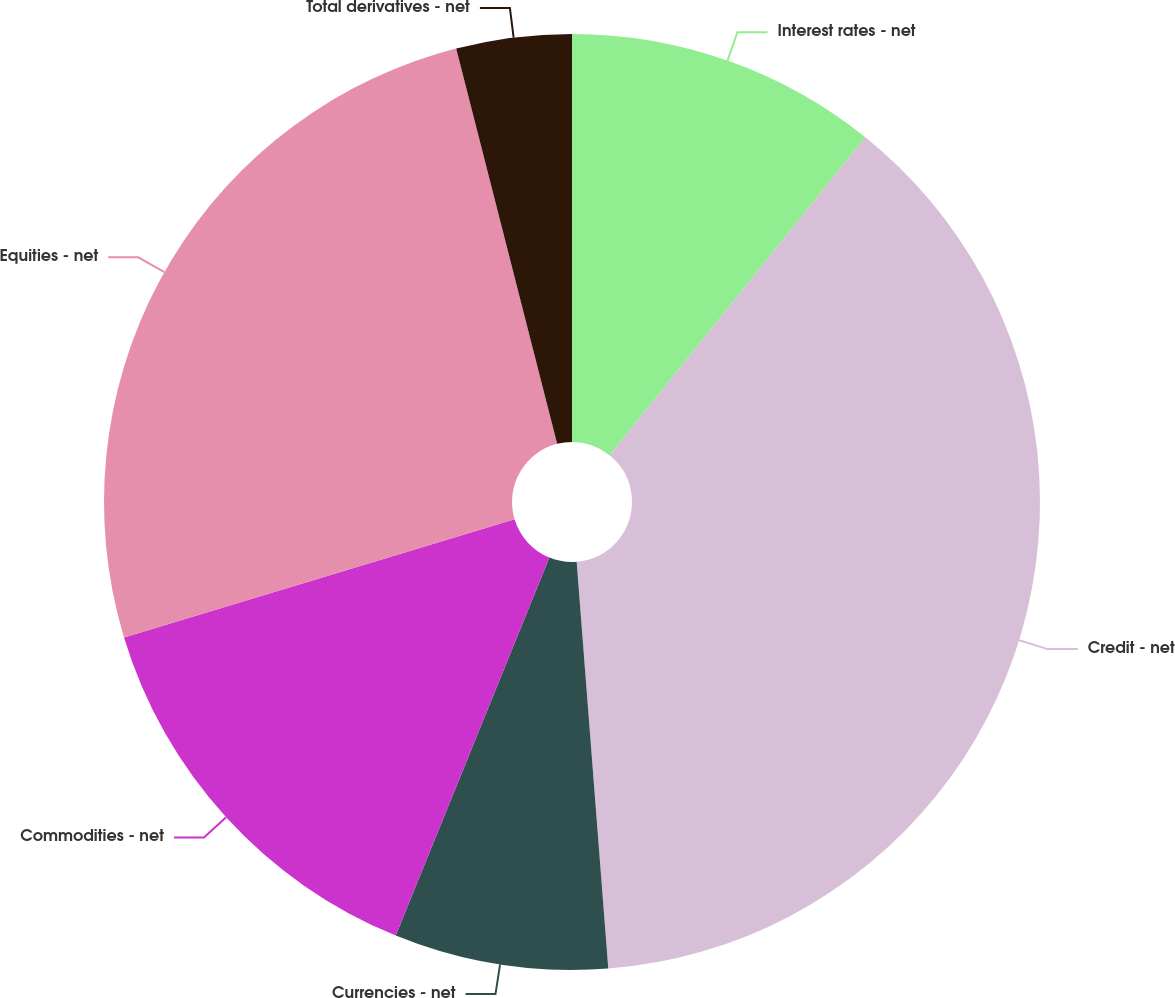<chart> <loc_0><loc_0><loc_500><loc_500><pie_chart><fcel>Interest rates - net<fcel>Credit - net<fcel>Currencies - net<fcel>Commodities - net<fcel>Equities - net<fcel>Total derivatives - net<nl><fcel>10.78%<fcel>37.98%<fcel>7.38%<fcel>14.18%<fcel>25.69%<fcel>3.98%<nl></chart> 